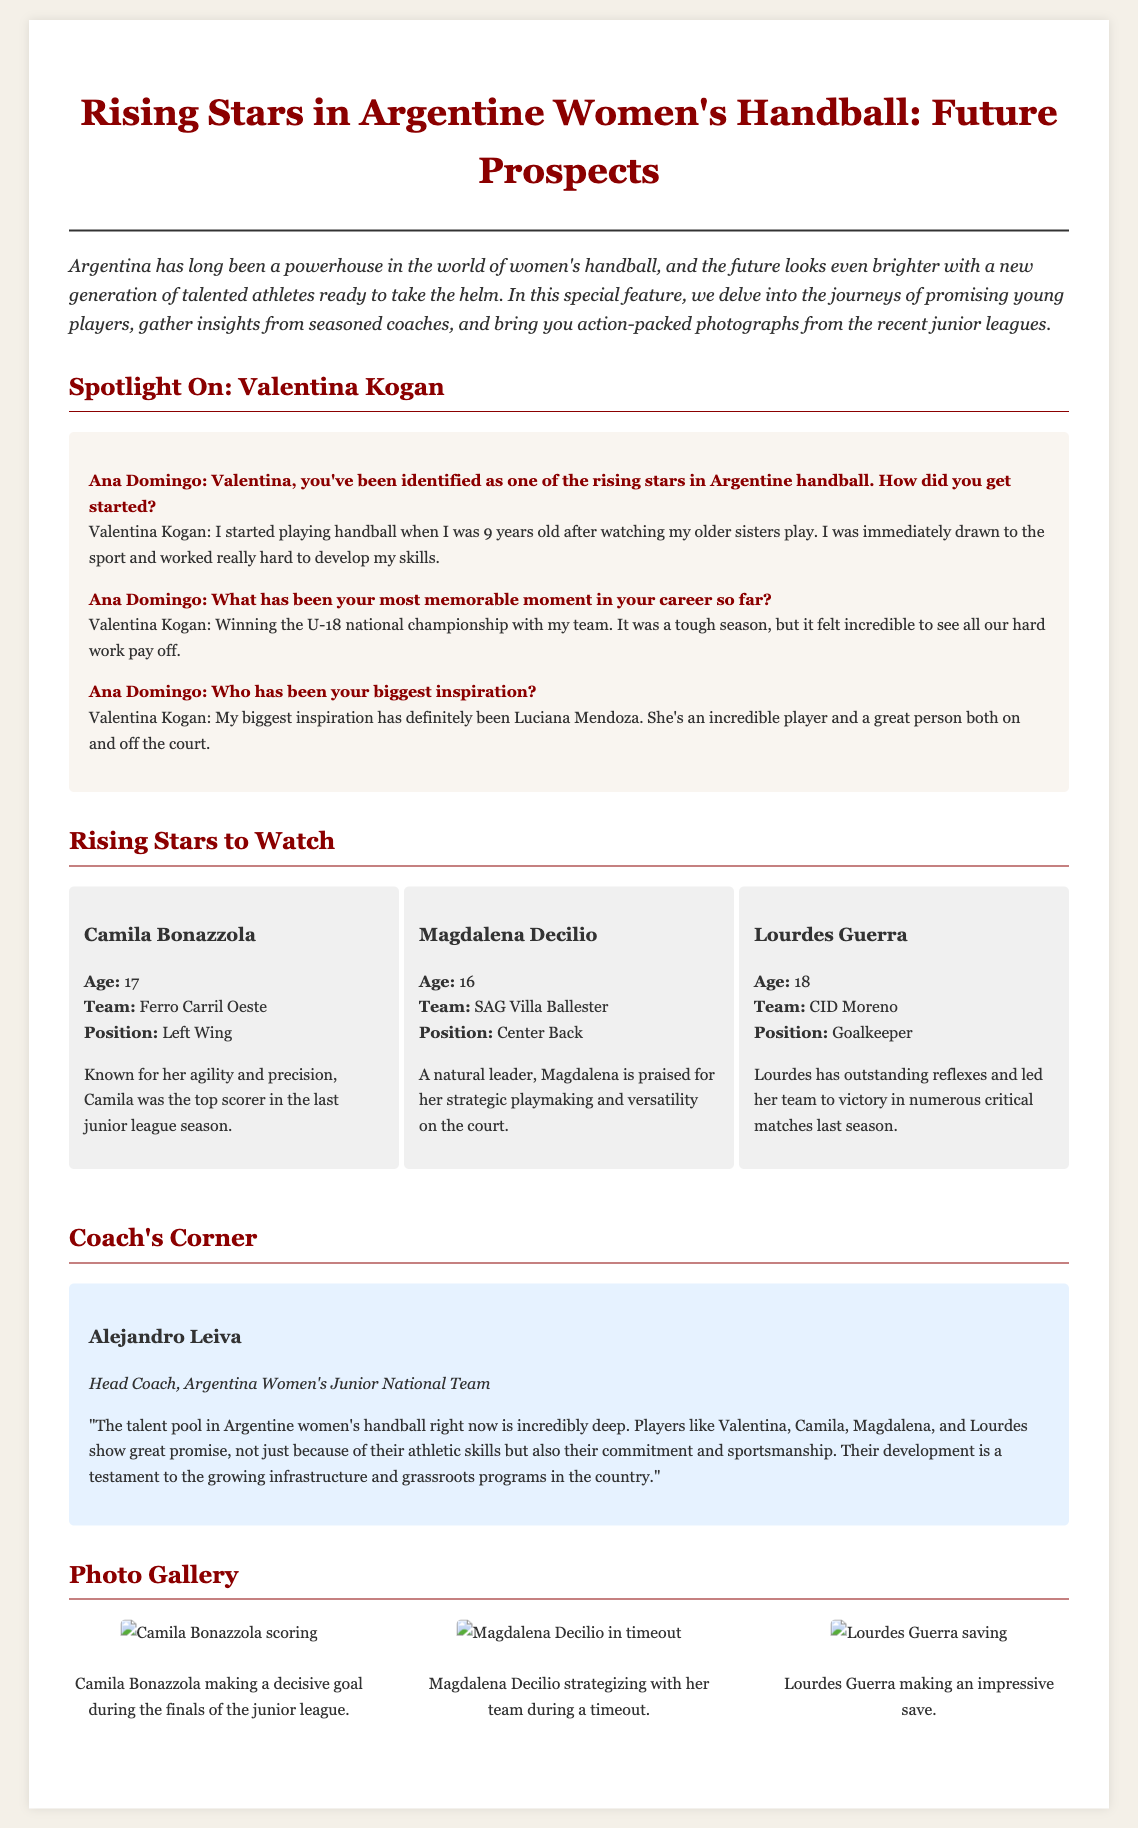What is Valentina Kogan's age? The document does not specify Valentina Kogan's age directly.
Answer: Not specified Which team does Camila Bonazzola play for? The document states that Camila Bonazzola plays for Ferro Carril Oeste.
Answer: Ferro Carril Oeste What position does Magdalena Decilio play? The document mentions that Magdalena Decilio plays as a Center Back.
Answer: Center Back Who is the head coach of the Argentina Women's Junior National Team? The document states that Alejandro Leiva is the head coach.
Answer: Alejandro Leiva What championship did Valentina Kogan win? The document indicates that Valentina Kogan won the U-18 national championship.
Answer: U-18 national championship How many young players are highlighted in the "Rising Stars to Watch" section? The section highlights three young players: Camila, Magdalena, and Lourdes.
Answer: Three What is the age of Lourdes Guerra? The document specifies that Lourdes Guerra is 18 years old.
Answer: 18 What notable quality is mentioned about Lourdes Guerra? It is mentioned that Lourdes has outstanding reflexes.
Answer: Outstanding reflexes Which player was noted as the top scorer in the last junior league season? The document states that Camila Bonazzola was the top scorer.
Answer: Camila Bonazzola 